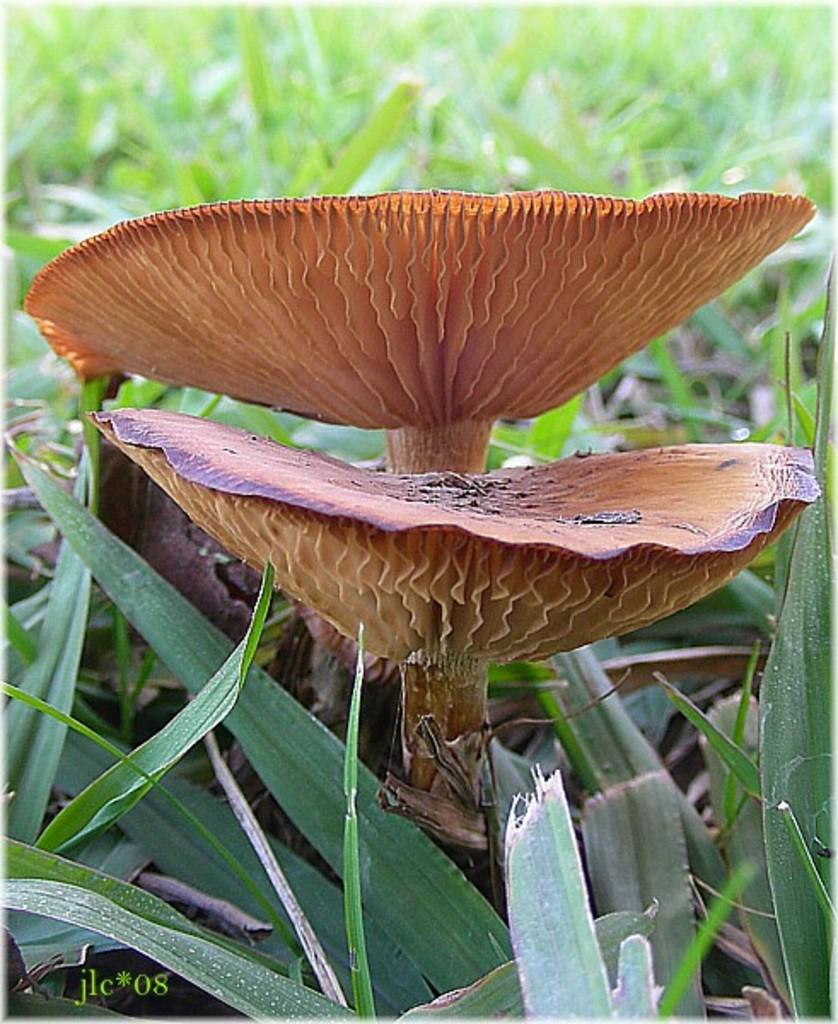What type of terrain is shown in the image? The image depicts a grassy land. Are there any specific objects or features visible on the grassy land? Yes, there are two mushrooms in the image. Can you see a swing in the image? No, there is no swing present in the image. Is there a rat hiding among the grass in the image? No, there is no rat visible in the image. 